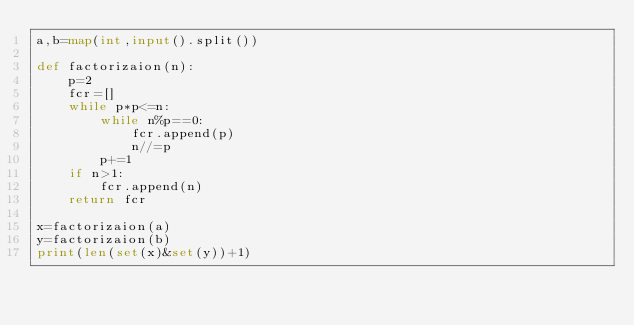<code> <loc_0><loc_0><loc_500><loc_500><_Python_>a,b=map(int,input().split())

def factorizaion(n):
    p=2
    fcr=[]
    while p*p<=n:
        while n%p==0:
            fcr.append(p)
            n//=p
        p+=1
    if n>1:
        fcr.append(n)
    return fcr

x=factorizaion(a)
y=factorizaion(b)
print(len(set(x)&set(y))+1)</code> 